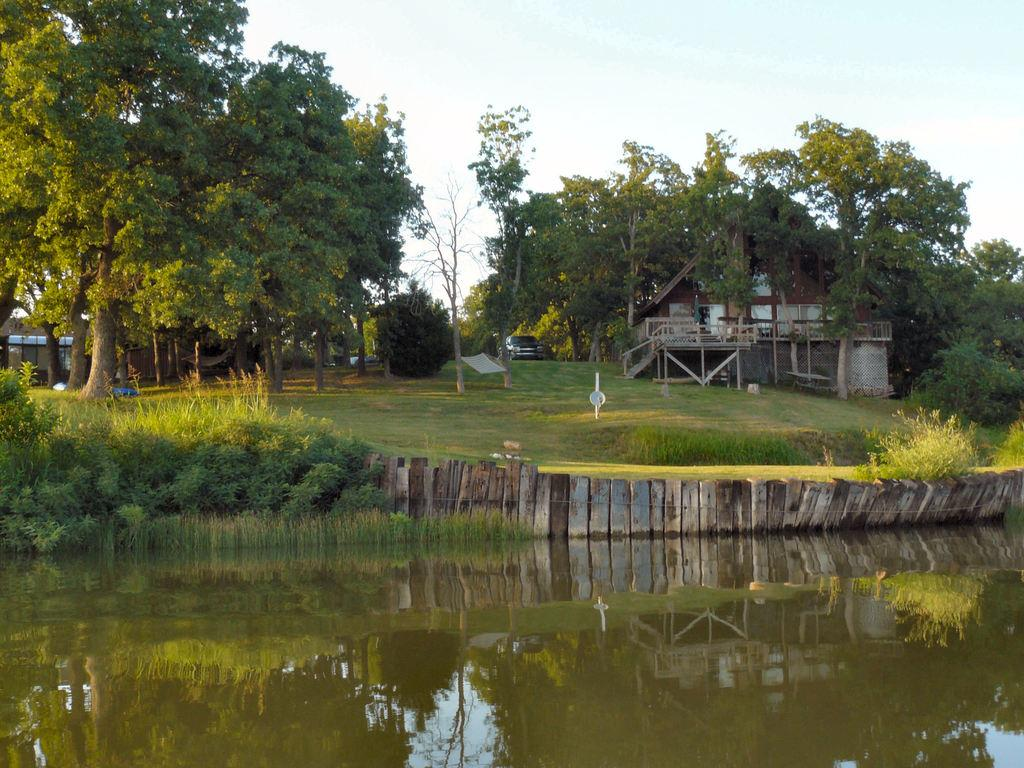What is the primary element visible in the image? There is water in the image. What type of vegetation can be seen in the image? There are plants, grass, and trees in the image. What type of structure is present in the image? There is a house in the image. Are there any architectural features in the image? Yes, there are stairs in the image. What else is visible in the image? There is a car in the image. What is visible at the top of the image? The sky is visible at the top of the image. What type of discussion is taking place between the earth and the lawyer in the image? There is no discussion between the earth and a lawyer present in the image, as neither an earth nor a lawyer is depicted. 